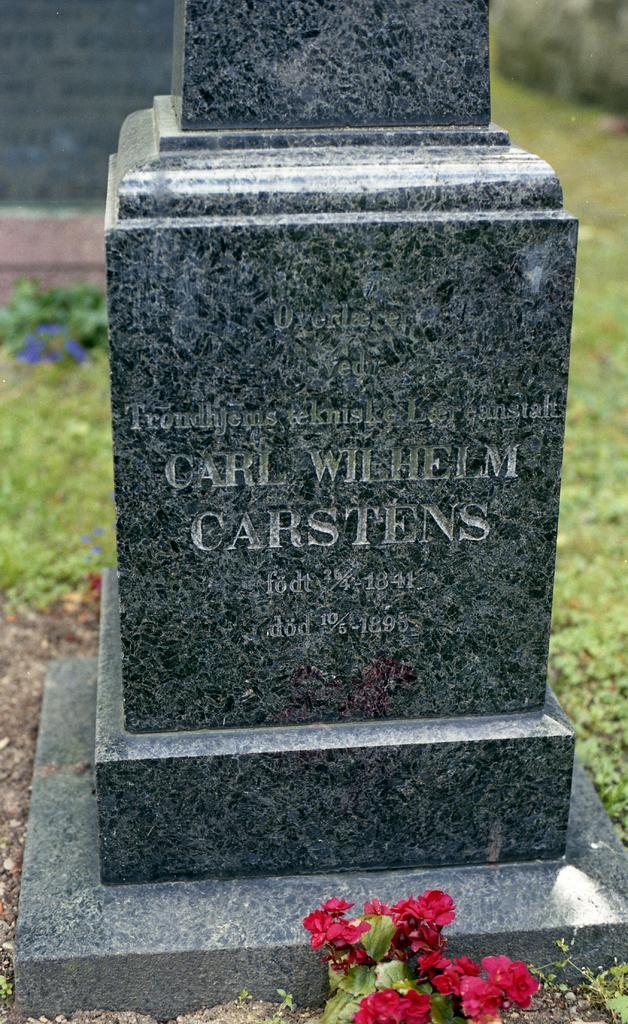How would you summarize this image in a sentence or two? This image is taken outdoors. In the background there is a ground with grass on it. There is a cornerstone. In the middle of the image there is a tombstone with a text on it. There is a bouquet on the ground. 